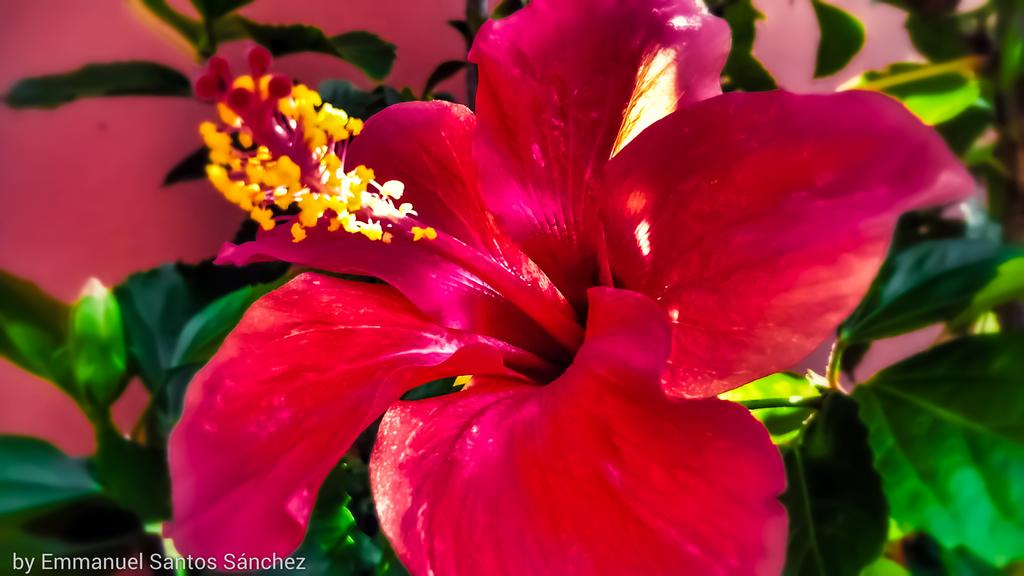What is the main subject of the image? There is a flower in the image. What can be seen in the background of the image? There are green leaves and a wall visible in the background of the image. Is there any text or marking on the image? Yes, there is a watermark at the bottom of the image. How does the wind affect the flower in the image? There is no indication of wind in the image, and therefore no effect on the flower can be observed. Can you see a bee interacting with the flower in the image? There is no bee present in the image; only the flower, green leaves, wall, and watermark are visible. 